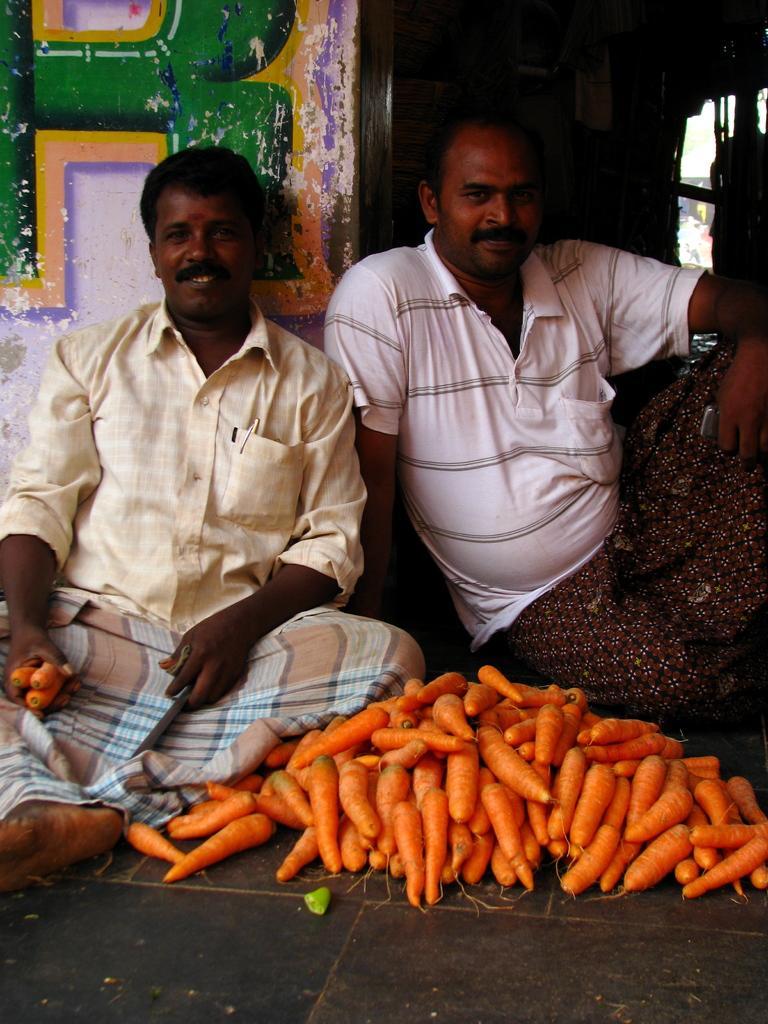Please provide a concise description of this image. In this image we can see two people sitting. The man sitting on the left is holding carrots. At the bottom there are carrots placed on the floor. In the background there is a door and a wall. 